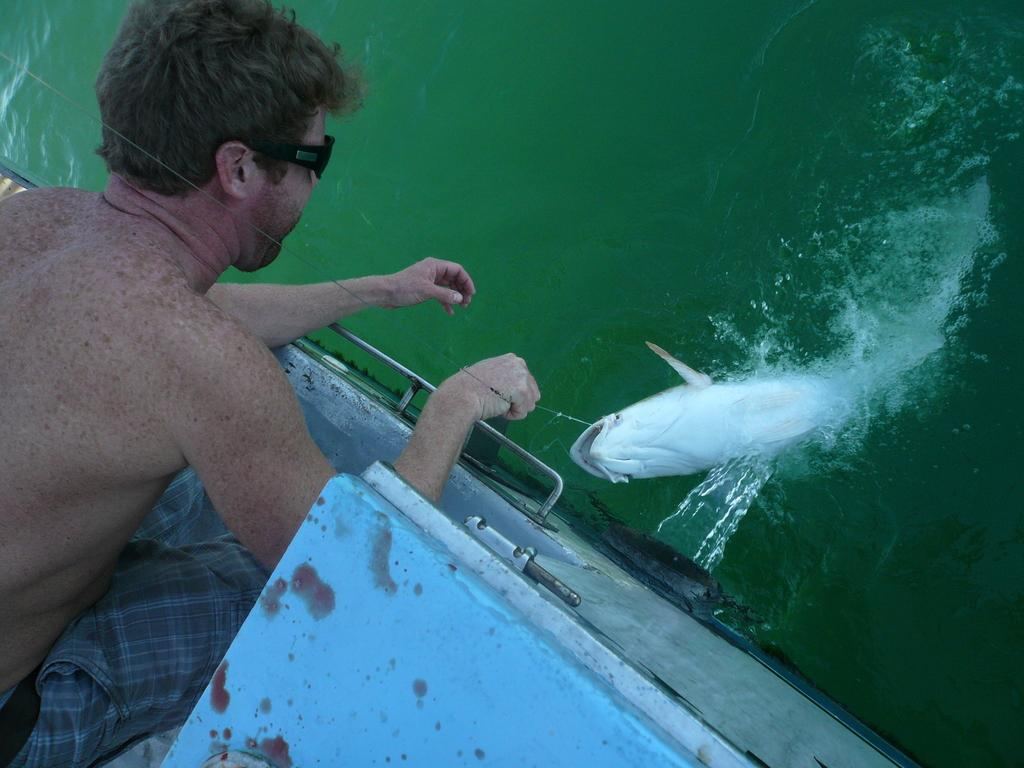Who is the main subject in the image? There is a person in the image. What is the person doing in the image? The person is in a boat and catching fish. What can be seen in the background of the image? There is water visible in the background of the image. What type of can does the actor use to catch fish in the image? There is no actor or can present in the image; the person is simply fishing with a fishing rod. 